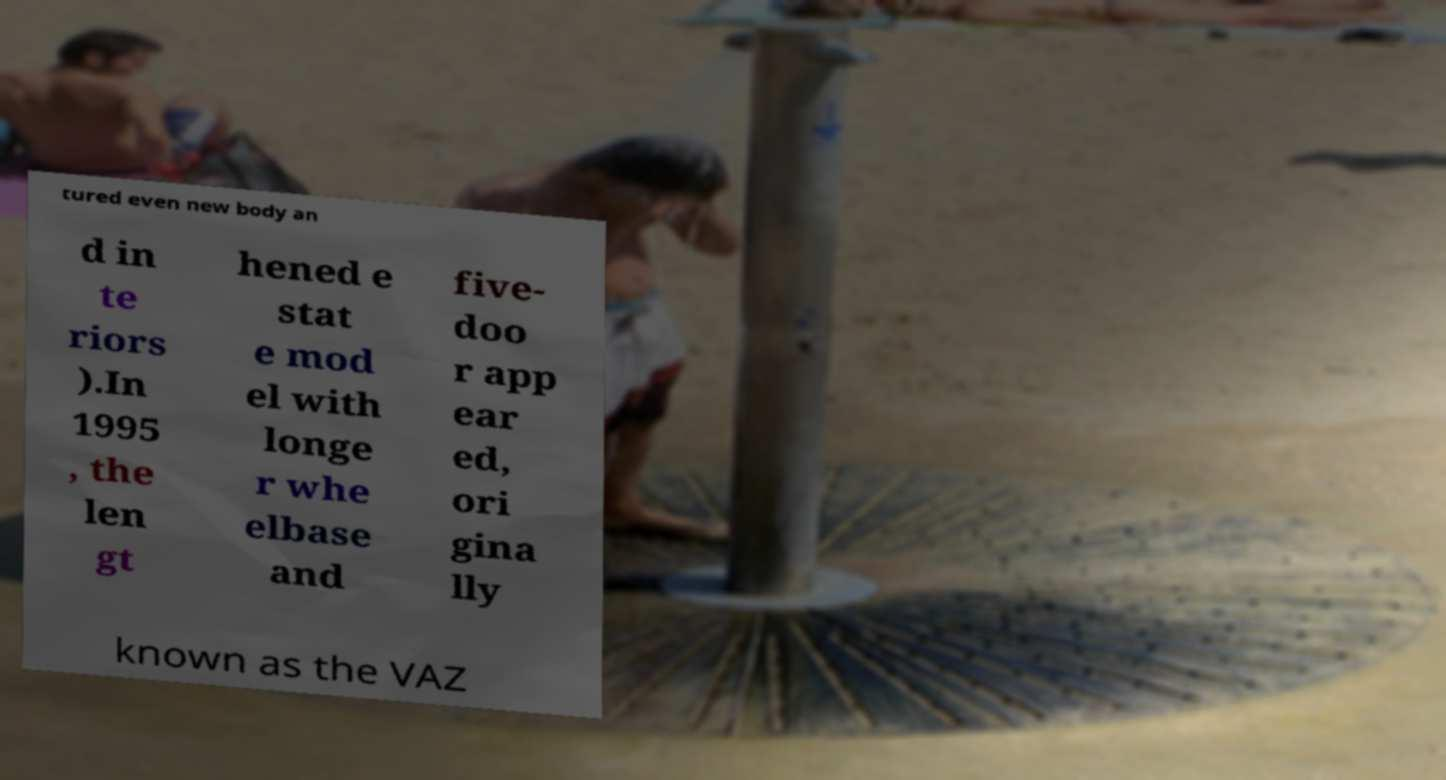For documentation purposes, I need the text within this image transcribed. Could you provide that? tured even new body an d in te riors ).In 1995 , the len gt hened e stat e mod el with longe r whe elbase and five- doo r app ear ed, ori gina lly known as the VAZ 